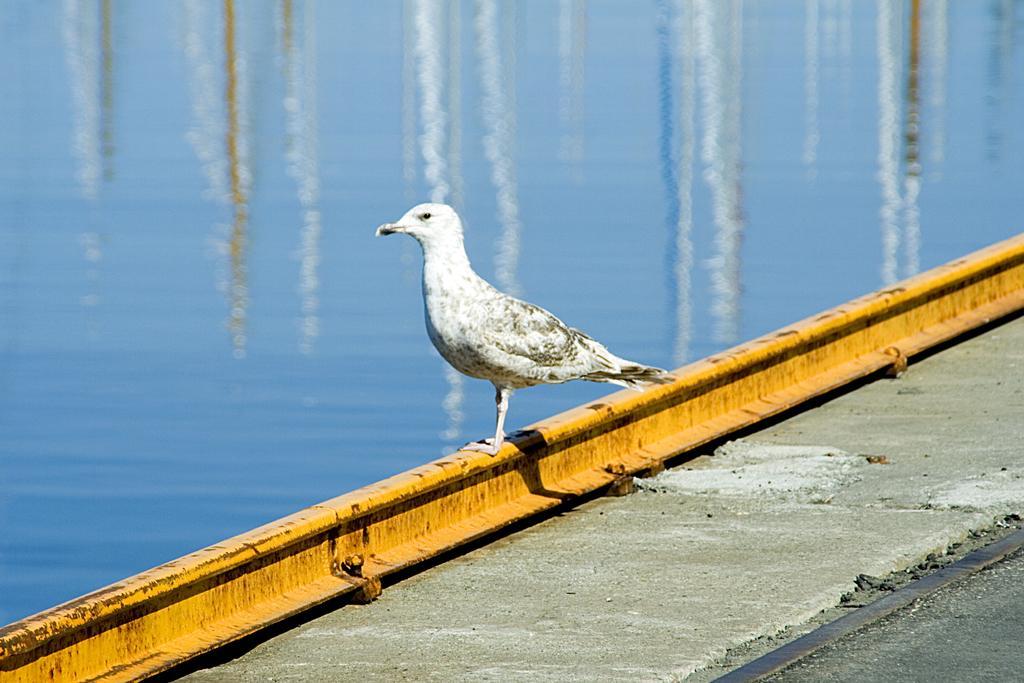Describe this image in one or two sentences. On the top of the image we can see water body. In the middle of the image we can see a bird which is white in color. In the foreground of the image we can see a platform. 